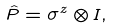Convert formula to latex. <formula><loc_0><loc_0><loc_500><loc_500>\hat { P } = \sigma ^ { z } \otimes I ,</formula> 